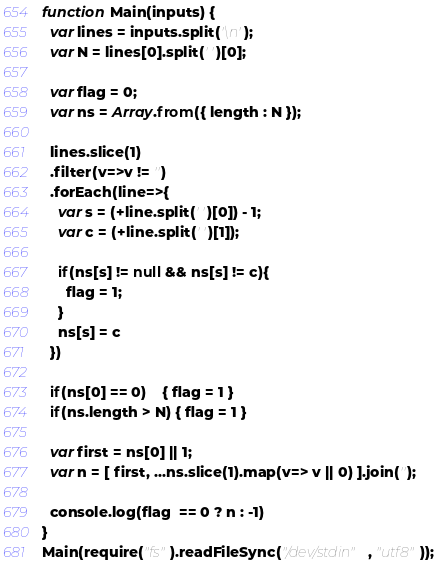Convert code to text. <code><loc_0><loc_0><loc_500><loc_500><_JavaScript_>function Main(inputs) {
  var lines = inputs.split('\n');
  var N = lines[0].split(' ')[0];

  var flag = 0;
  var ns = Array.from({ length : N });

  lines.slice(1)
  .filter(v=>v != '')
  .forEach(line=>{
    var s = (+line.split(' ')[0]) - 1;
    var c = (+line.split(' ')[1]);

    if(ns[s] != null && ns[s] != c){
      flag = 1;
    }
    ns[s] = c
  })

  if(ns[0] == 0)    { flag = 1 }
  if(ns.length > N) { flag = 1 }

  var first = ns[0] || 1;
  var n = [ first, ...ns.slice(1).map(v=> v || 0) ].join('');

  console.log(flag  == 0 ? n : -1)
}
Main(require("fs").readFileSync("/dev/stdin", "utf8"));

</code> 